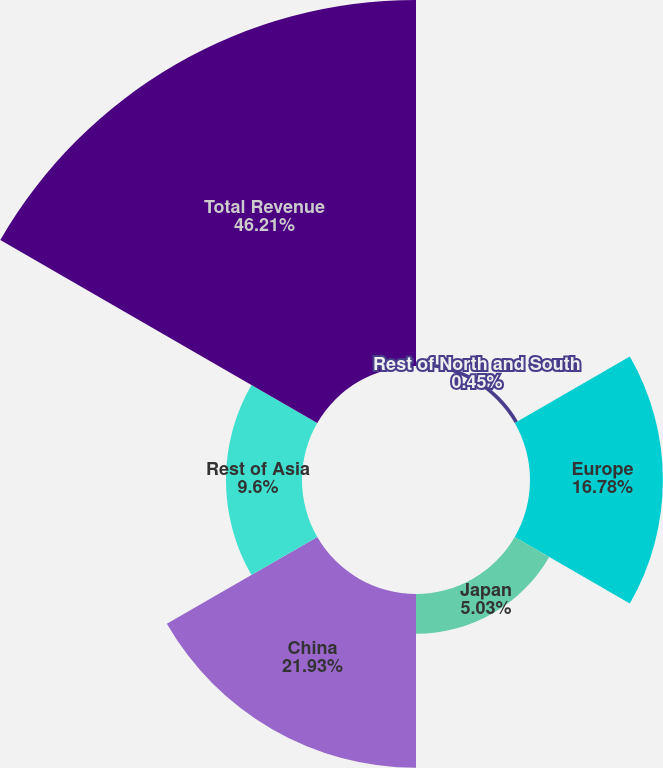<chart> <loc_0><loc_0><loc_500><loc_500><pie_chart><fcel>Rest of North and South<fcel>Europe<fcel>Japan<fcel>China<fcel>Rest of Asia<fcel>Total Revenue<nl><fcel>0.45%<fcel>16.78%<fcel>5.03%<fcel>21.93%<fcel>9.6%<fcel>46.21%<nl></chart> 